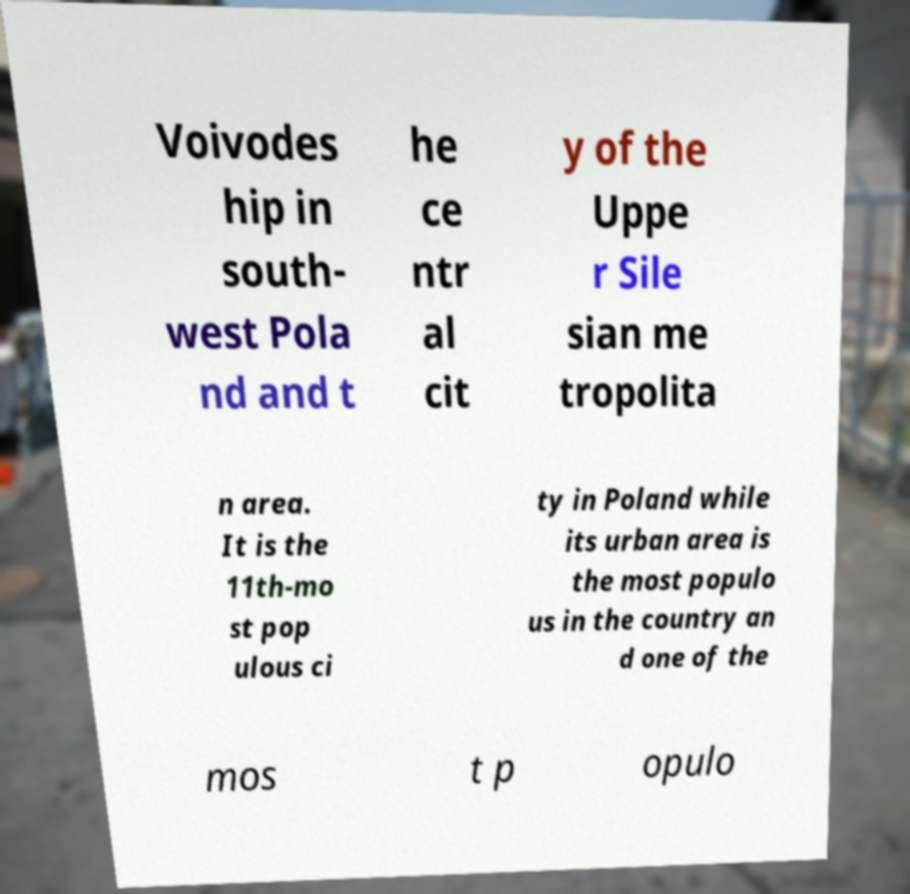What messages or text are displayed in this image? I need them in a readable, typed format. Voivodes hip in south- west Pola nd and t he ce ntr al cit y of the Uppe r Sile sian me tropolita n area. It is the 11th-mo st pop ulous ci ty in Poland while its urban area is the most populo us in the country an d one of the mos t p opulo 